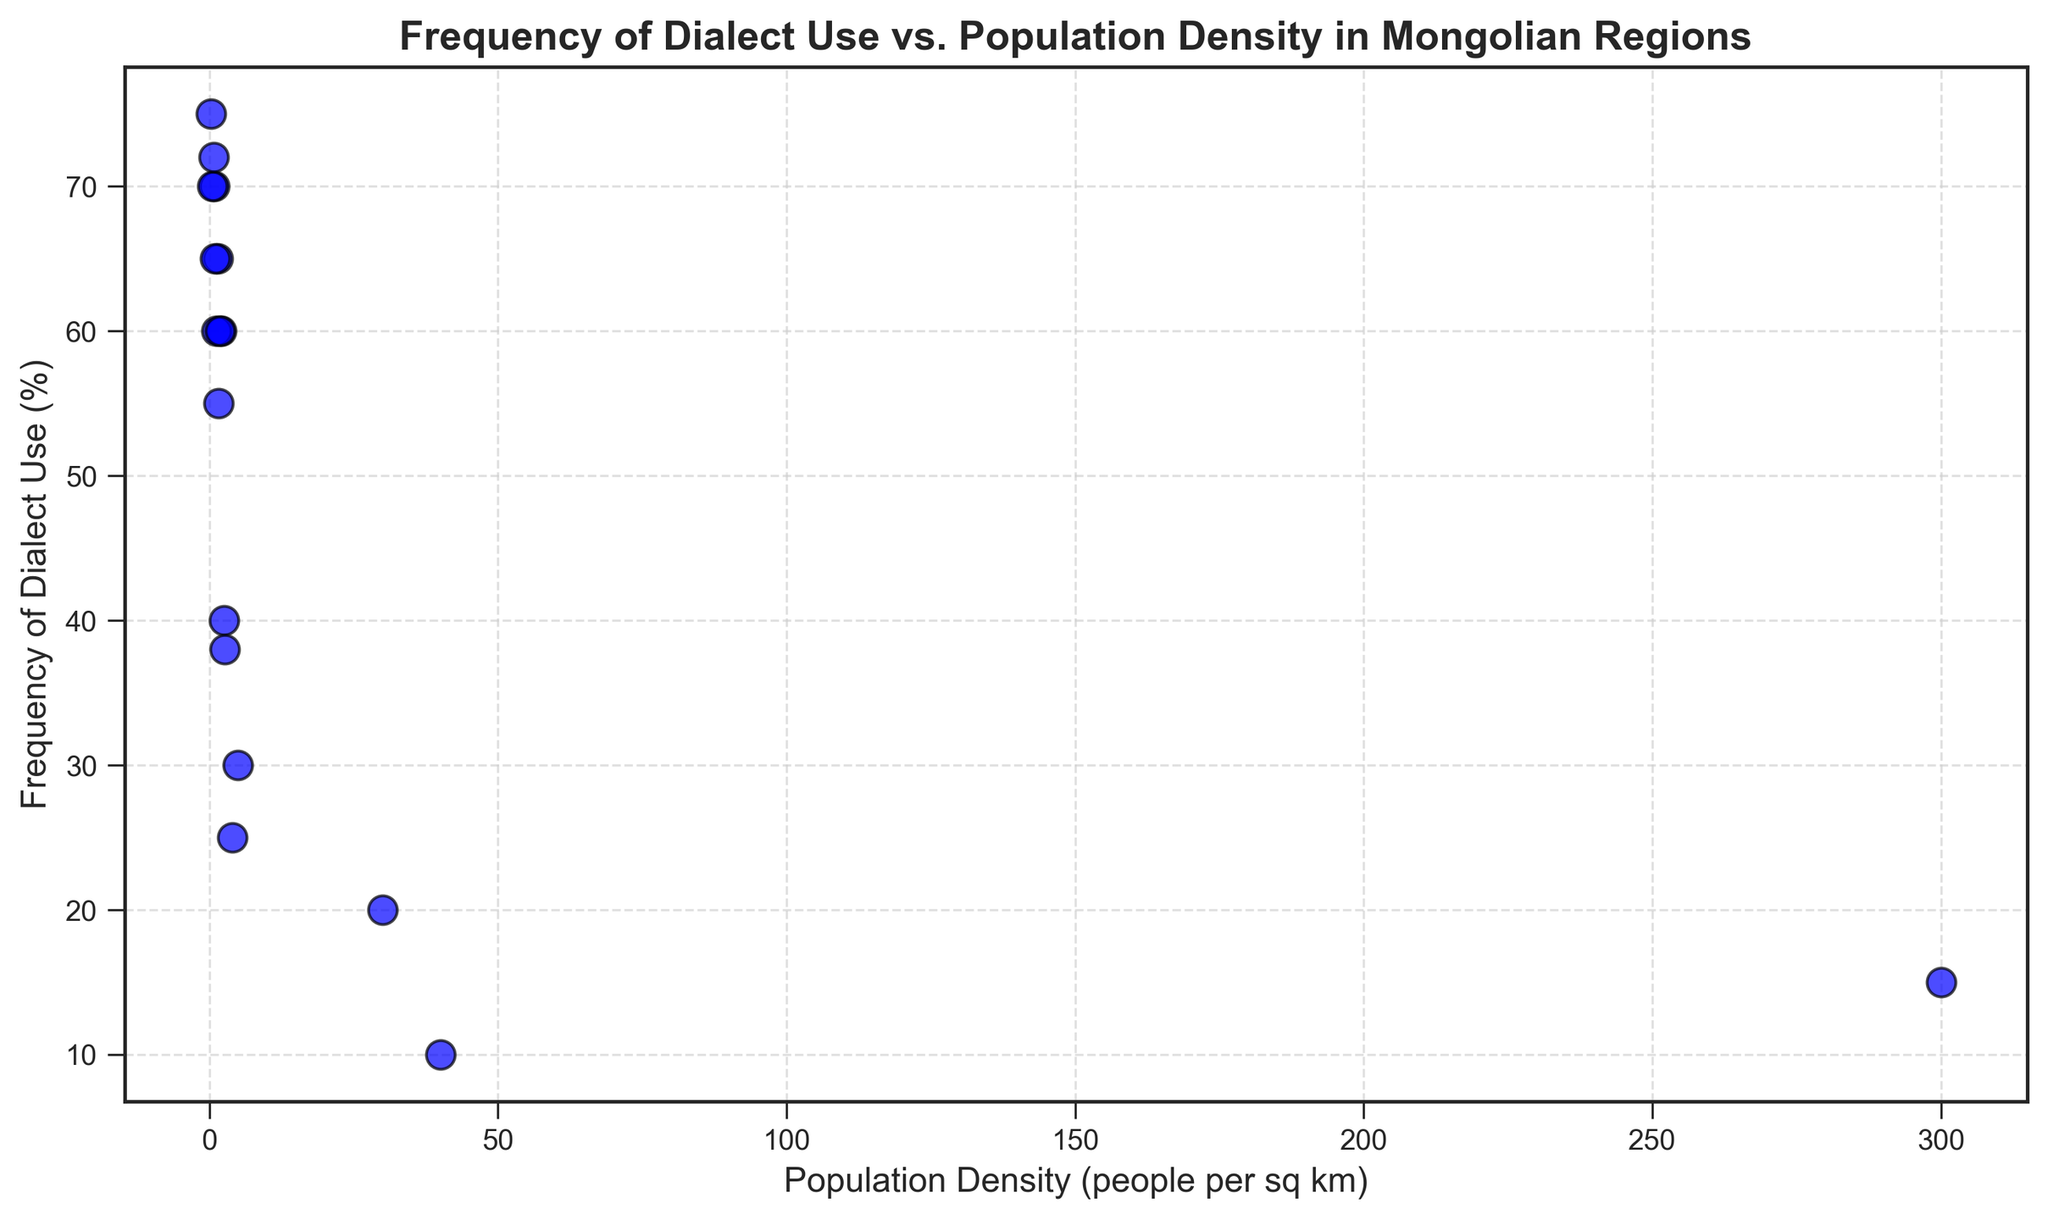Which region has the highest frequency of dialect use? By observing the vertical axis (Frequency of Dialect Use (%)), the region located at the highest position on the scatter plot represents the region with the highest frequency. The datapoint for Dundgovi is the one with the highest value of 75%.
Answer: Dundgovi Which region has the least population density? By looking at the horizontal axis (Population Density (people per sq km)), the leftmost point on the scatter plot is the region with the least population density. Dundgovi has the lowest value of 0.3 people per sq km.
Answer: Dundgovi How does Ulaanbaatar compare to Darkhan-Uul in population density and frequency of dialect use? For population density, Ulaanbaatar is placed further right than Darkhan-Uul on the x-axis, indicating a higher value (300 vs. 30 people per sq km). For frequency of dialect use, Ulaanbaatar is lower on the y-axis compared to Darkhan-Uul, indicating a lower value (15% vs. 20%).
Answer: Ulaanbaatar has higher population density but lower frequency of dialect use Which regions have a similar frequency of dialect use around 60%? Points around the 60% mark on the y-axis indicate the regions. Khovd, Dornod, Govisumber, Khuvsgul, and Khentii all have frequencies around this value.
Answer: Khovd, Dornod, Govisumber, Khuvsgul, Khentii What can be said about the relationship between population density and frequency of dialect use? By observing the scatter plot, it is evident that regions with higher population densities tend to have lower frequencies of dialect use, and regions with lower population densities have higher frequencies.
Answer: Inverse relationship Which region has the highest frequency of dialect use among regions with population density lower than 1 person per sq km? Only regions with population density <1 should be considered. Among these, Uvs with 0.8 people per sq km and 72% dialect use is the highest.
Answer: Uvs What is the mean frequency of dialect use for the regions Khovd, Dornod, and Govisumber? Sum the frequency percentages for Khovd (65%), Dornod (60%), and Govisumber (60%), and divide by the number of regions (3). (65 + 60 + 60) / 3 = 185 / 3 = 61.67%.
Answer: 61.67% Identify the outlier(s) with the highest population density. The point far right on the x-axis is for Ulaanbaatar with 300 people per sq km, significantly higher than other regions.
Answer: Ulaanbaatar Which region has a lower frequency of dialect use: Orkhon or Selenge? By comparing the vertical positions, Orkhon is at 10%, whereas Selenge is at 25% on the y-axis, making Orkhon's frequency lower.
Answer: Orkhon 